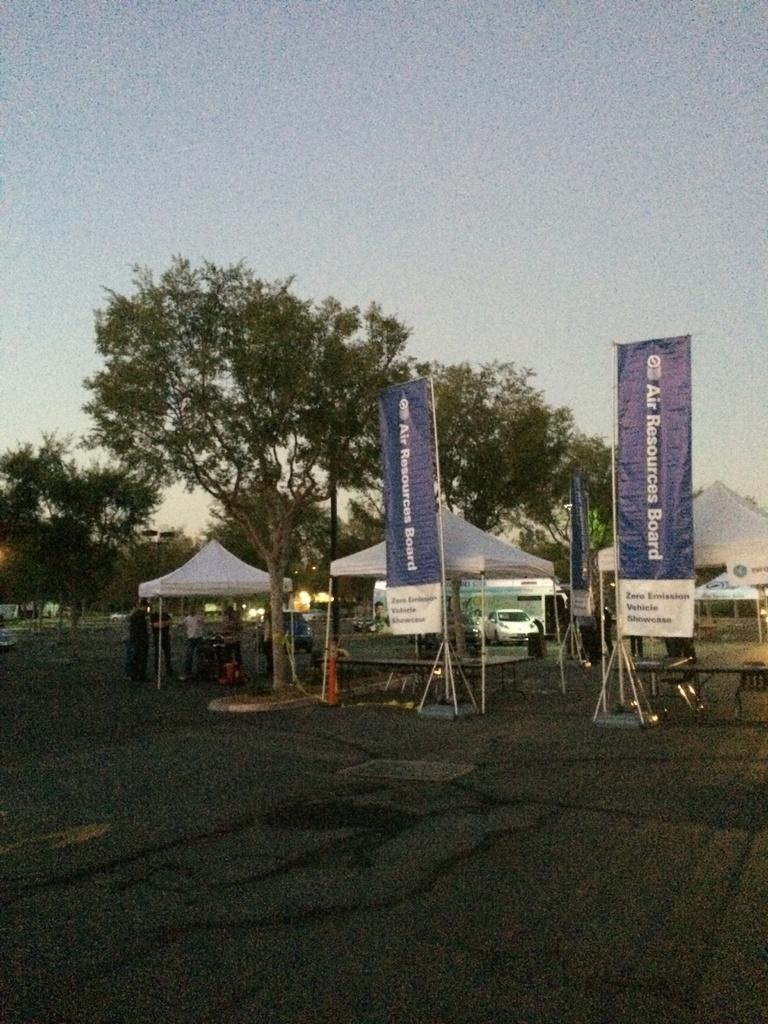How would you summarize this image in a sentence or two? This picture shows few trees and we see few tents and couple of banners and we see couple of cars parked and few people standing on the road and we see a cloudy sky. 